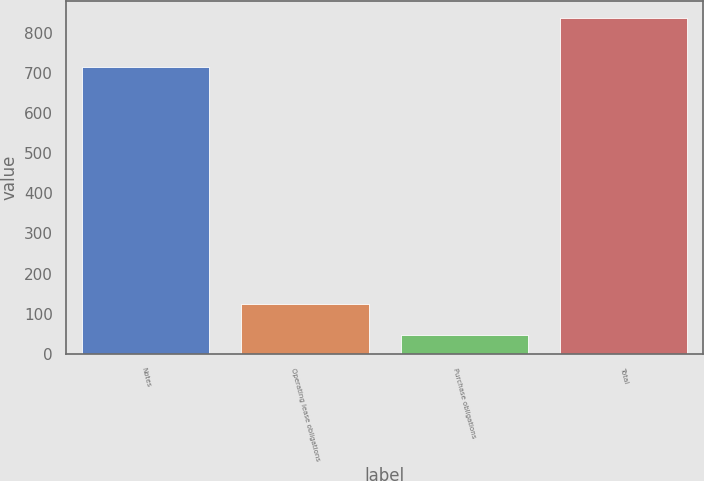<chart> <loc_0><loc_0><loc_500><loc_500><bar_chart><fcel>Notes<fcel>Operating lease obligations<fcel>Purchase obligations<fcel>Total<nl><fcel>714.8<fcel>125.46<fcel>46.5<fcel>836.1<nl></chart> 